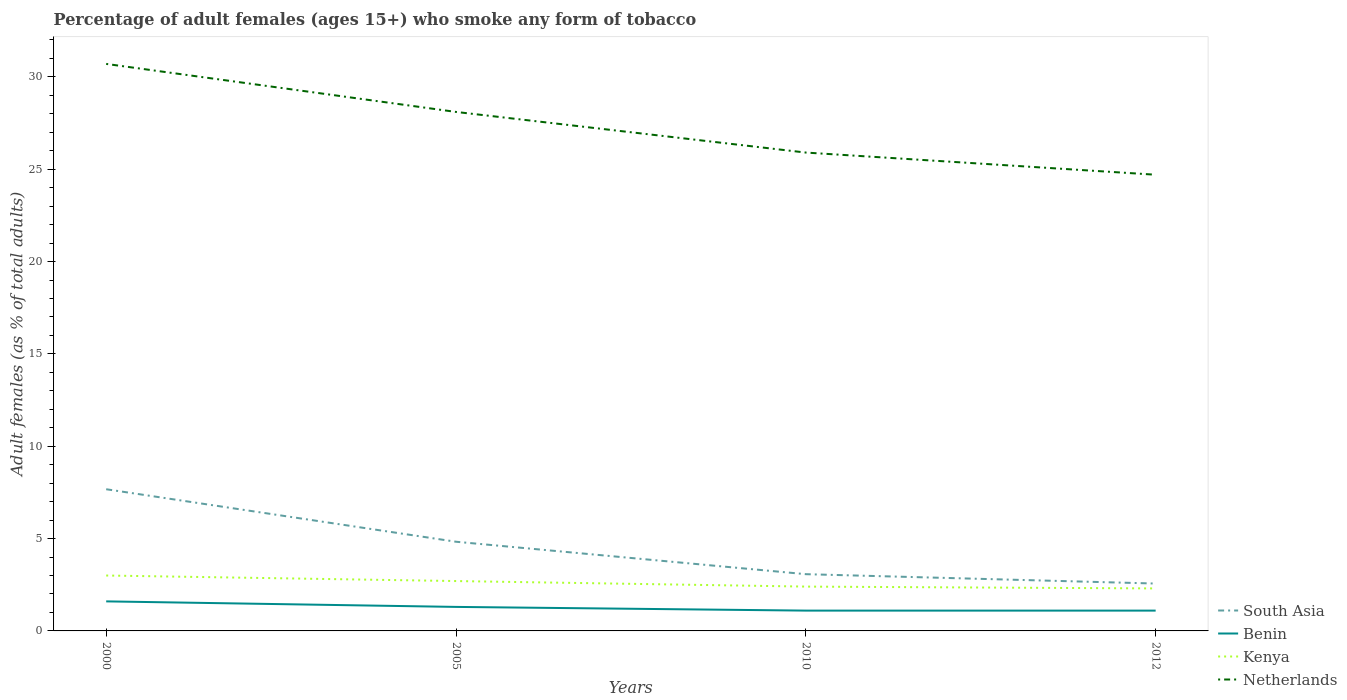How many different coloured lines are there?
Your response must be concise. 4. Does the line corresponding to Netherlands intersect with the line corresponding to South Asia?
Provide a short and direct response. No. Is the number of lines equal to the number of legend labels?
Make the answer very short. Yes. Across all years, what is the maximum percentage of adult females who smoke in Kenya?
Offer a very short reply. 2.3. What is the total percentage of adult females who smoke in Netherlands in the graph?
Your answer should be very brief. 3.4. What is the difference between the highest and the second highest percentage of adult females who smoke in Kenya?
Provide a short and direct response. 0.7. What is the difference between the highest and the lowest percentage of adult females who smoke in Benin?
Your answer should be compact. 2. Is the percentage of adult females who smoke in Kenya strictly greater than the percentage of adult females who smoke in South Asia over the years?
Provide a short and direct response. Yes. How many lines are there?
Provide a short and direct response. 4. How many years are there in the graph?
Make the answer very short. 4. What is the difference between two consecutive major ticks on the Y-axis?
Your response must be concise. 5. Are the values on the major ticks of Y-axis written in scientific E-notation?
Offer a terse response. No. Does the graph contain any zero values?
Ensure brevity in your answer.  No. Where does the legend appear in the graph?
Your answer should be compact. Bottom right. What is the title of the graph?
Your answer should be very brief. Percentage of adult females (ages 15+) who smoke any form of tobacco. Does "Romania" appear as one of the legend labels in the graph?
Give a very brief answer. No. What is the label or title of the X-axis?
Provide a short and direct response. Years. What is the label or title of the Y-axis?
Make the answer very short. Adult females (as % of total adults). What is the Adult females (as % of total adults) of South Asia in 2000?
Provide a succinct answer. 7.67. What is the Adult females (as % of total adults) in Benin in 2000?
Ensure brevity in your answer.  1.6. What is the Adult females (as % of total adults) of Kenya in 2000?
Provide a short and direct response. 3. What is the Adult females (as % of total adults) in Netherlands in 2000?
Offer a very short reply. 30.7. What is the Adult females (as % of total adults) of South Asia in 2005?
Provide a succinct answer. 4.83. What is the Adult females (as % of total adults) in Benin in 2005?
Offer a very short reply. 1.3. What is the Adult females (as % of total adults) of Kenya in 2005?
Provide a succinct answer. 2.7. What is the Adult females (as % of total adults) in Netherlands in 2005?
Keep it short and to the point. 28.1. What is the Adult females (as % of total adults) of South Asia in 2010?
Give a very brief answer. 3.07. What is the Adult females (as % of total adults) in Kenya in 2010?
Give a very brief answer. 2.4. What is the Adult females (as % of total adults) in Netherlands in 2010?
Give a very brief answer. 25.9. What is the Adult females (as % of total adults) in South Asia in 2012?
Keep it short and to the point. 2.56. What is the Adult females (as % of total adults) of Netherlands in 2012?
Your answer should be very brief. 24.7. Across all years, what is the maximum Adult females (as % of total adults) of South Asia?
Offer a terse response. 7.67. Across all years, what is the maximum Adult females (as % of total adults) in Kenya?
Provide a succinct answer. 3. Across all years, what is the maximum Adult females (as % of total adults) of Netherlands?
Your response must be concise. 30.7. Across all years, what is the minimum Adult females (as % of total adults) of South Asia?
Your answer should be very brief. 2.56. Across all years, what is the minimum Adult females (as % of total adults) in Benin?
Keep it short and to the point. 1.1. Across all years, what is the minimum Adult females (as % of total adults) of Netherlands?
Offer a very short reply. 24.7. What is the total Adult females (as % of total adults) of South Asia in the graph?
Give a very brief answer. 18.14. What is the total Adult females (as % of total adults) in Kenya in the graph?
Offer a very short reply. 10.4. What is the total Adult females (as % of total adults) of Netherlands in the graph?
Make the answer very short. 109.4. What is the difference between the Adult females (as % of total adults) of South Asia in 2000 and that in 2005?
Your answer should be compact. 2.84. What is the difference between the Adult females (as % of total adults) of Netherlands in 2000 and that in 2005?
Provide a short and direct response. 2.6. What is the difference between the Adult females (as % of total adults) of South Asia in 2000 and that in 2010?
Offer a very short reply. 4.6. What is the difference between the Adult females (as % of total adults) of Benin in 2000 and that in 2010?
Your response must be concise. 0.5. What is the difference between the Adult females (as % of total adults) in Kenya in 2000 and that in 2010?
Your answer should be very brief. 0.6. What is the difference between the Adult females (as % of total adults) in South Asia in 2000 and that in 2012?
Keep it short and to the point. 5.11. What is the difference between the Adult females (as % of total adults) in Benin in 2000 and that in 2012?
Ensure brevity in your answer.  0.5. What is the difference between the Adult females (as % of total adults) of South Asia in 2005 and that in 2010?
Your answer should be compact. 1.76. What is the difference between the Adult females (as % of total adults) of Kenya in 2005 and that in 2010?
Offer a terse response. 0.3. What is the difference between the Adult females (as % of total adults) in South Asia in 2005 and that in 2012?
Make the answer very short. 2.26. What is the difference between the Adult females (as % of total adults) in Benin in 2005 and that in 2012?
Make the answer very short. 0.2. What is the difference between the Adult females (as % of total adults) of South Asia in 2010 and that in 2012?
Offer a very short reply. 0.51. What is the difference between the Adult females (as % of total adults) of Netherlands in 2010 and that in 2012?
Provide a succinct answer. 1.2. What is the difference between the Adult females (as % of total adults) of South Asia in 2000 and the Adult females (as % of total adults) of Benin in 2005?
Provide a short and direct response. 6.37. What is the difference between the Adult females (as % of total adults) of South Asia in 2000 and the Adult females (as % of total adults) of Kenya in 2005?
Offer a terse response. 4.97. What is the difference between the Adult females (as % of total adults) in South Asia in 2000 and the Adult females (as % of total adults) in Netherlands in 2005?
Provide a succinct answer. -20.43. What is the difference between the Adult females (as % of total adults) of Benin in 2000 and the Adult females (as % of total adults) of Netherlands in 2005?
Make the answer very short. -26.5. What is the difference between the Adult females (as % of total adults) in Kenya in 2000 and the Adult females (as % of total adults) in Netherlands in 2005?
Make the answer very short. -25.1. What is the difference between the Adult females (as % of total adults) of South Asia in 2000 and the Adult females (as % of total adults) of Benin in 2010?
Your answer should be compact. 6.57. What is the difference between the Adult females (as % of total adults) of South Asia in 2000 and the Adult females (as % of total adults) of Kenya in 2010?
Provide a succinct answer. 5.27. What is the difference between the Adult females (as % of total adults) of South Asia in 2000 and the Adult females (as % of total adults) of Netherlands in 2010?
Offer a terse response. -18.23. What is the difference between the Adult females (as % of total adults) of Benin in 2000 and the Adult females (as % of total adults) of Netherlands in 2010?
Keep it short and to the point. -24.3. What is the difference between the Adult females (as % of total adults) in Kenya in 2000 and the Adult females (as % of total adults) in Netherlands in 2010?
Ensure brevity in your answer.  -22.9. What is the difference between the Adult females (as % of total adults) of South Asia in 2000 and the Adult females (as % of total adults) of Benin in 2012?
Provide a succinct answer. 6.57. What is the difference between the Adult females (as % of total adults) in South Asia in 2000 and the Adult females (as % of total adults) in Kenya in 2012?
Provide a succinct answer. 5.37. What is the difference between the Adult females (as % of total adults) of South Asia in 2000 and the Adult females (as % of total adults) of Netherlands in 2012?
Ensure brevity in your answer.  -17.03. What is the difference between the Adult females (as % of total adults) of Benin in 2000 and the Adult females (as % of total adults) of Netherlands in 2012?
Offer a very short reply. -23.1. What is the difference between the Adult females (as % of total adults) in Kenya in 2000 and the Adult females (as % of total adults) in Netherlands in 2012?
Your response must be concise. -21.7. What is the difference between the Adult females (as % of total adults) in South Asia in 2005 and the Adult females (as % of total adults) in Benin in 2010?
Your response must be concise. 3.73. What is the difference between the Adult females (as % of total adults) of South Asia in 2005 and the Adult females (as % of total adults) of Kenya in 2010?
Provide a succinct answer. 2.43. What is the difference between the Adult females (as % of total adults) of South Asia in 2005 and the Adult females (as % of total adults) of Netherlands in 2010?
Provide a succinct answer. -21.07. What is the difference between the Adult females (as % of total adults) in Benin in 2005 and the Adult females (as % of total adults) in Kenya in 2010?
Offer a very short reply. -1.1. What is the difference between the Adult females (as % of total adults) in Benin in 2005 and the Adult females (as % of total adults) in Netherlands in 2010?
Offer a very short reply. -24.6. What is the difference between the Adult females (as % of total adults) in Kenya in 2005 and the Adult females (as % of total adults) in Netherlands in 2010?
Provide a succinct answer. -23.2. What is the difference between the Adult females (as % of total adults) in South Asia in 2005 and the Adult females (as % of total adults) in Benin in 2012?
Make the answer very short. 3.73. What is the difference between the Adult females (as % of total adults) of South Asia in 2005 and the Adult females (as % of total adults) of Kenya in 2012?
Provide a short and direct response. 2.53. What is the difference between the Adult females (as % of total adults) in South Asia in 2005 and the Adult females (as % of total adults) in Netherlands in 2012?
Provide a succinct answer. -19.87. What is the difference between the Adult females (as % of total adults) in Benin in 2005 and the Adult females (as % of total adults) in Netherlands in 2012?
Give a very brief answer. -23.4. What is the difference between the Adult females (as % of total adults) in Kenya in 2005 and the Adult females (as % of total adults) in Netherlands in 2012?
Make the answer very short. -22. What is the difference between the Adult females (as % of total adults) of South Asia in 2010 and the Adult females (as % of total adults) of Benin in 2012?
Ensure brevity in your answer.  1.97. What is the difference between the Adult females (as % of total adults) in South Asia in 2010 and the Adult females (as % of total adults) in Kenya in 2012?
Offer a terse response. 0.77. What is the difference between the Adult females (as % of total adults) in South Asia in 2010 and the Adult females (as % of total adults) in Netherlands in 2012?
Make the answer very short. -21.63. What is the difference between the Adult females (as % of total adults) in Benin in 2010 and the Adult females (as % of total adults) in Kenya in 2012?
Ensure brevity in your answer.  -1.2. What is the difference between the Adult females (as % of total adults) in Benin in 2010 and the Adult females (as % of total adults) in Netherlands in 2012?
Your answer should be compact. -23.6. What is the difference between the Adult females (as % of total adults) in Kenya in 2010 and the Adult females (as % of total adults) in Netherlands in 2012?
Make the answer very short. -22.3. What is the average Adult females (as % of total adults) of South Asia per year?
Your response must be concise. 4.53. What is the average Adult females (as % of total adults) of Benin per year?
Your response must be concise. 1.27. What is the average Adult females (as % of total adults) of Kenya per year?
Provide a succinct answer. 2.6. What is the average Adult females (as % of total adults) of Netherlands per year?
Offer a terse response. 27.35. In the year 2000, what is the difference between the Adult females (as % of total adults) of South Asia and Adult females (as % of total adults) of Benin?
Ensure brevity in your answer.  6.07. In the year 2000, what is the difference between the Adult females (as % of total adults) of South Asia and Adult females (as % of total adults) of Kenya?
Provide a short and direct response. 4.67. In the year 2000, what is the difference between the Adult females (as % of total adults) of South Asia and Adult females (as % of total adults) of Netherlands?
Provide a short and direct response. -23.03. In the year 2000, what is the difference between the Adult females (as % of total adults) of Benin and Adult females (as % of total adults) of Kenya?
Provide a short and direct response. -1.4. In the year 2000, what is the difference between the Adult females (as % of total adults) of Benin and Adult females (as % of total adults) of Netherlands?
Offer a very short reply. -29.1. In the year 2000, what is the difference between the Adult females (as % of total adults) in Kenya and Adult females (as % of total adults) in Netherlands?
Provide a succinct answer. -27.7. In the year 2005, what is the difference between the Adult females (as % of total adults) of South Asia and Adult females (as % of total adults) of Benin?
Your answer should be compact. 3.53. In the year 2005, what is the difference between the Adult females (as % of total adults) of South Asia and Adult females (as % of total adults) of Kenya?
Provide a succinct answer. 2.13. In the year 2005, what is the difference between the Adult females (as % of total adults) in South Asia and Adult females (as % of total adults) in Netherlands?
Provide a short and direct response. -23.27. In the year 2005, what is the difference between the Adult females (as % of total adults) of Benin and Adult females (as % of total adults) of Kenya?
Make the answer very short. -1.4. In the year 2005, what is the difference between the Adult females (as % of total adults) of Benin and Adult females (as % of total adults) of Netherlands?
Keep it short and to the point. -26.8. In the year 2005, what is the difference between the Adult females (as % of total adults) of Kenya and Adult females (as % of total adults) of Netherlands?
Your answer should be very brief. -25.4. In the year 2010, what is the difference between the Adult females (as % of total adults) in South Asia and Adult females (as % of total adults) in Benin?
Your response must be concise. 1.97. In the year 2010, what is the difference between the Adult females (as % of total adults) in South Asia and Adult females (as % of total adults) in Kenya?
Keep it short and to the point. 0.67. In the year 2010, what is the difference between the Adult females (as % of total adults) in South Asia and Adult females (as % of total adults) in Netherlands?
Your answer should be very brief. -22.83. In the year 2010, what is the difference between the Adult females (as % of total adults) of Benin and Adult females (as % of total adults) of Netherlands?
Your answer should be very brief. -24.8. In the year 2010, what is the difference between the Adult females (as % of total adults) in Kenya and Adult females (as % of total adults) in Netherlands?
Offer a terse response. -23.5. In the year 2012, what is the difference between the Adult females (as % of total adults) of South Asia and Adult females (as % of total adults) of Benin?
Provide a succinct answer. 1.46. In the year 2012, what is the difference between the Adult females (as % of total adults) in South Asia and Adult females (as % of total adults) in Kenya?
Your answer should be compact. 0.26. In the year 2012, what is the difference between the Adult females (as % of total adults) in South Asia and Adult females (as % of total adults) in Netherlands?
Your response must be concise. -22.14. In the year 2012, what is the difference between the Adult females (as % of total adults) in Benin and Adult females (as % of total adults) in Kenya?
Offer a terse response. -1.2. In the year 2012, what is the difference between the Adult females (as % of total adults) of Benin and Adult females (as % of total adults) of Netherlands?
Offer a very short reply. -23.6. In the year 2012, what is the difference between the Adult females (as % of total adults) of Kenya and Adult females (as % of total adults) of Netherlands?
Your response must be concise. -22.4. What is the ratio of the Adult females (as % of total adults) in South Asia in 2000 to that in 2005?
Your answer should be compact. 1.59. What is the ratio of the Adult females (as % of total adults) in Benin in 2000 to that in 2005?
Give a very brief answer. 1.23. What is the ratio of the Adult females (as % of total adults) in Kenya in 2000 to that in 2005?
Offer a very short reply. 1.11. What is the ratio of the Adult females (as % of total adults) in Netherlands in 2000 to that in 2005?
Provide a short and direct response. 1.09. What is the ratio of the Adult females (as % of total adults) in South Asia in 2000 to that in 2010?
Offer a terse response. 2.5. What is the ratio of the Adult females (as % of total adults) in Benin in 2000 to that in 2010?
Keep it short and to the point. 1.45. What is the ratio of the Adult females (as % of total adults) of Kenya in 2000 to that in 2010?
Keep it short and to the point. 1.25. What is the ratio of the Adult females (as % of total adults) of Netherlands in 2000 to that in 2010?
Ensure brevity in your answer.  1.19. What is the ratio of the Adult females (as % of total adults) of South Asia in 2000 to that in 2012?
Provide a short and direct response. 2.99. What is the ratio of the Adult females (as % of total adults) in Benin in 2000 to that in 2012?
Provide a short and direct response. 1.45. What is the ratio of the Adult females (as % of total adults) in Kenya in 2000 to that in 2012?
Keep it short and to the point. 1.3. What is the ratio of the Adult females (as % of total adults) of Netherlands in 2000 to that in 2012?
Offer a terse response. 1.24. What is the ratio of the Adult females (as % of total adults) of South Asia in 2005 to that in 2010?
Provide a succinct answer. 1.57. What is the ratio of the Adult females (as % of total adults) of Benin in 2005 to that in 2010?
Ensure brevity in your answer.  1.18. What is the ratio of the Adult females (as % of total adults) in Kenya in 2005 to that in 2010?
Keep it short and to the point. 1.12. What is the ratio of the Adult females (as % of total adults) of Netherlands in 2005 to that in 2010?
Your answer should be very brief. 1.08. What is the ratio of the Adult females (as % of total adults) in South Asia in 2005 to that in 2012?
Ensure brevity in your answer.  1.88. What is the ratio of the Adult females (as % of total adults) in Benin in 2005 to that in 2012?
Ensure brevity in your answer.  1.18. What is the ratio of the Adult females (as % of total adults) in Kenya in 2005 to that in 2012?
Make the answer very short. 1.17. What is the ratio of the Adult females (as % of total adults) of Netherlands in 2005 to that in 2012?
Your answer should be very brief. 1.14. What is the ratio of the Adult females (as % of total adults) of South Asia in 2010 to that in 2012?
Ensure brevity in your answer.  1.2. What is the ratio of the Adult females (as % of total adults) of Kenya in 2010 to that in 2012?
Your response must be concise. 1.04. What is the ratio of the Adult females (as % of total adults) of Netherlands in 2010 to that in 2012?
Keep it short and to the point. 1.05. What is the difference between the highest and the second highest Adult females (as % of total adults) of South Asia?
Offer a terse response. 2.84. What is the difference between the highest and the second highest Adult females (as % of total adults) in Kenya?
Offer a very short reply. 0.3. What is the difference between the highest and the lowest Adult females (as % of total adults) in South Asia?
Your answer should be compact. 5.11. What is the difference between the highest and the lowest Adult females (as % of total adults) of Kenya?
Keep it short and to the point. 0.7. 